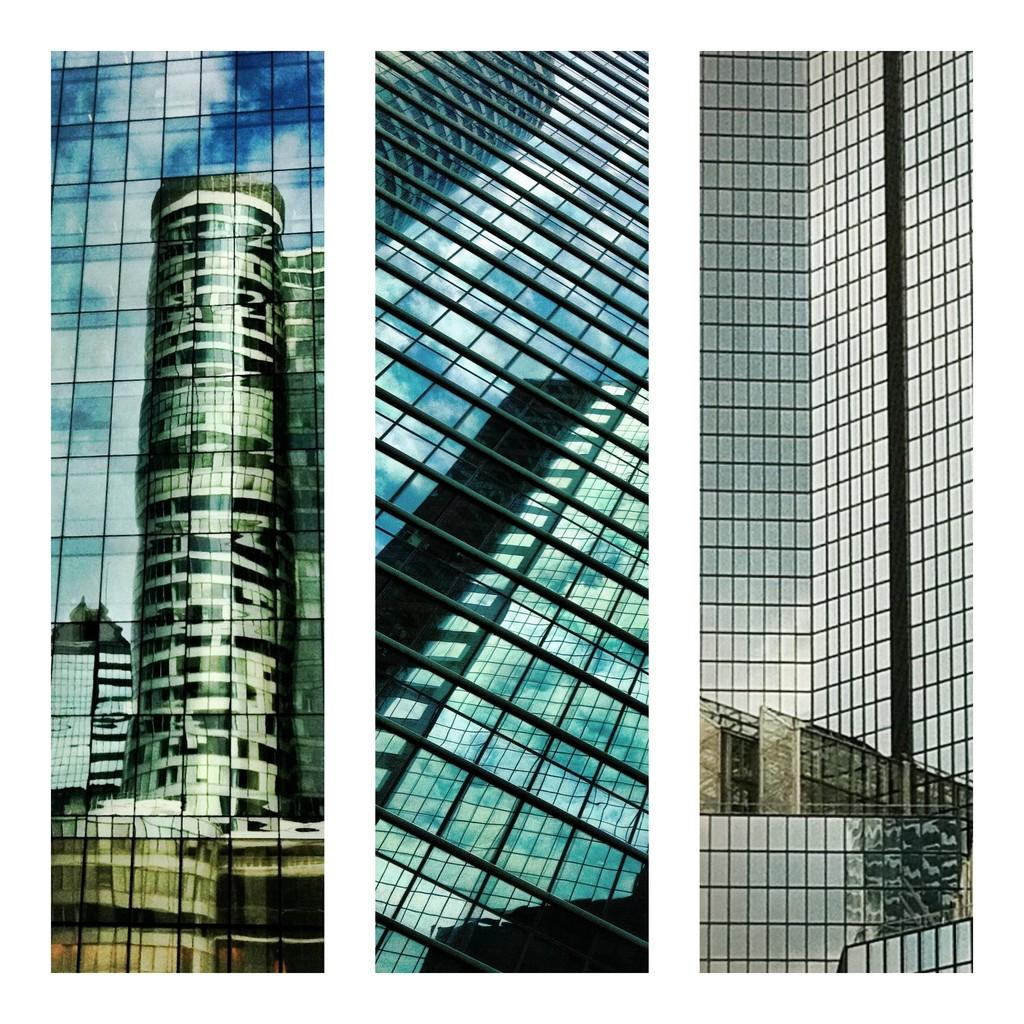What type of artwork is the image? The image is a collage. What type of structures can be seen in the collage? There are buildings in the image. What type of bottle is featured in the collage? There is no bottle present in the collage; it only features buildings. What is the plot of the story depicted in the collage? The image is a collage, not a story, so there is no plot to describe. 